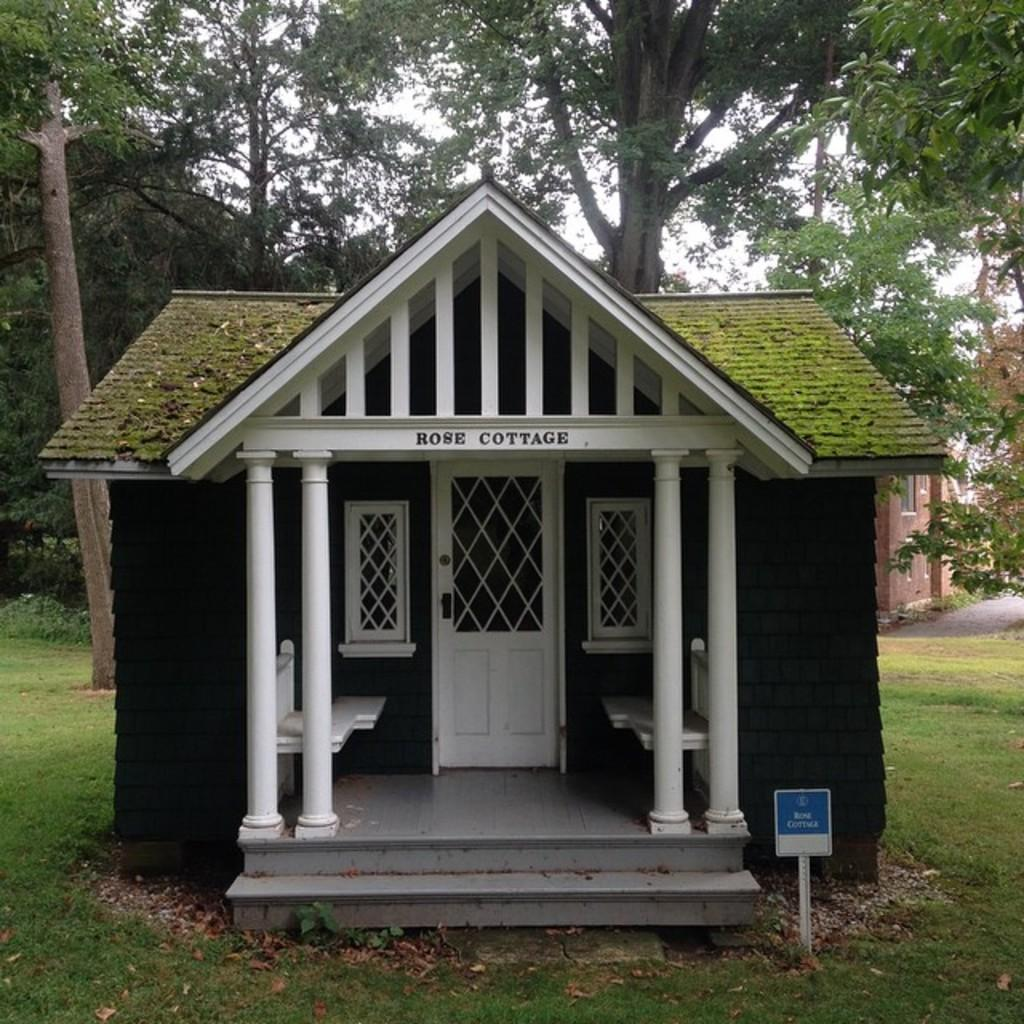What is the main structure in the center of the image? There is a cottage in the center of the image. What can be seen in the background of the image? There are trees and the sky visible in the background of the image. What type of vegetation is present at the bottom of the image? There is grass at the bottom of the image. What object is located at the bottom of the image? There is a board at the bottom of the image. How many grapes are hanging from the trees in the image? There are no grapes visible in the image; only trees are present in the background. 